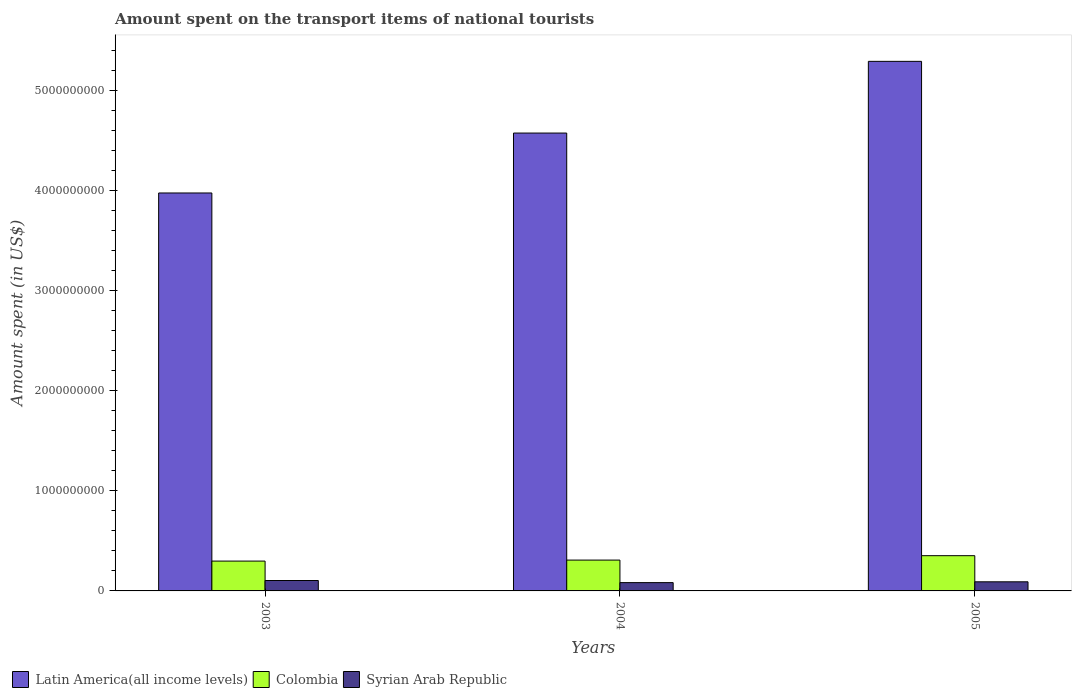Are the number of bars on each tick of the X-axis equal?
Your answer should be very brief. Yes. How many bars are there on the 1st tick from the right?
Your answer should be compact. 3. In how many cases, is the number of bars for a given year not equal to the number of legend labels?
Your answer should be compact. 0. What is the amount spent on the transport items of national tourists in Colombia in 2005?
Keep it short and to the point. 3.52e+08. Across all years, what is the maximum amount spent on the transport items of national tourists in Colombia?
Give a very brief answer. 3.52e+08. Across all years, what is the minimum amount spent on the transport items of national tourists in Colombia?
Your answer should be compact. 2.98e+08. In which year was the amount spent on the transport items of national tourists in Latin America(all income levels) maximum?
Your answer should be very brief. 2005. What is the total amount spent on the transport items of national tourists in Syrian Arab Republic in the graph?
Offer a terse response. 2.78e+08. What is the difference between the amount spent on the transport items of national tourists in Syrian Arab Republic in 2004 and that in 2005?
Make the answer very short. -8.00e+06. What is the difference between the amount spent on the transport items of national tourists in Colombia in 2005 and the amount spent on the transport items of national tourists in Latin America(all income levels) in 2004?
Offer a terse response. -4.22e+09. What is the average amount spent on the transport items of national tourists in Colombia per year?
Your answer should be compact. 3.19e+08. In the year 2004, what is the difference between the amount spent on the transport items of national tourists in Syrian Arab Republic and amount spent on the transport items of national tourists in Latin America(all income levels)?
Provide a succinct answer. -4.49e+09. In how many years, is the amount spent on the transport items of national tourists in Syrian Arab Republic greater than 3000000000 US$?
Offer a terse response. 0. What is the ratio of the amount spent on the transport items of national tourists in Colombia in 2003 to that in 2005?
Your answer should be compact. 0.85. Is the amount spent on the transport items of national tourists in Colombia in 2003 less than that in 2004?
Keep it short and to the point. Yes. Is the difference between the amount spent on the transport items of national tourists in Syrian Arab Republic in 2004 and 2005 greater than the difference between the amount spent on the transport items of national tourists in Latin America(all income levels) in 2004 and 2005?
Provide a succinct answer. Yes. What is the difference between the highest and the second highest amount spent on the transport items of national tourists in Syrian Arab Republic?
Provide a short and direct response. 1.30e+07. What is the difference between the highest and the lowest amount spent on the transport items of national tourists in Colombia?
Offer a terse response. 5.40e+07. In how many years, is the amount spent on the transport items of national tourists in Latin America(all income levels) greater than the average amount spent on the transport items of national tourists in Latin America(all income levels) taken over all years?
Your answer should be compact. 1. What does the 3rd bar from the left in 2003 represents?
Your answer should be very brief. Syrian Arab Republic. What does the 1st bar from the right in 2004 represents?
Keep it short and to the point. Syrian Arab Republic. How many bars are there?
Keep it short and to the point. 9. Are all the bars in the graph horizontal?
Provide a short and direct response. No. How many years are there in the graph?
Make the answer very short. 3. What is the difference between two consecutive major ticks on the Y-axis?
Your answer should be compact. 1.00e+09. Does the graph contain grids?
Offer a terse response. No. How many legend labels are there?
Offer a very short reply. 3. What is the title of the graph?
Offer a very short reply. Amount spent on the transport items of national tourists. Does "Spain" appear as one of the legend labels in the graph?
Your answer should be compact. No. What is the label or title of the Y-axis?
Give a very brief answer. Amount spent (in US$). What is the Amount spent (in US$) of Latin America(all income levels) in 2003?
Give a very brief answer. 3.98e+09. What is the Amount spent (in US$) in Colombia in 2003?
Keep it short and to the point. 2.98e+08. What is the Amount spent (in US$) of Syrian Arab Republic in 2003?
Provide a succinct answer. 1.04e+08. What is the Amount spent (in US$) of Latin America(all income levels) in 2004?
Ensure brevity in your answer.  4.57e+09. What is the Amount spent (in US$) in Colombia in 2004?
Provide a succinct answer. 3.08e+08. What is the Amount spent (in US$) of Syrian Arab Republic in 2004?
Give a very brief answer. 8.30e+07. What is the Amount spent (in US$) of Latin America(all income levels) in 2005?
Offer a very short reply. 5.29e+09. What is the Amount spent (in US$) of Colombia in 2005?
Give a very brief answer. 3.52e+08. What is the Amount spent (in US$) in Syrian Arab Republic in 2005?
Keep it short and to the point. 9.10e+07. Across all years, what is the maximum Amount spent (in US$) of Latin America(all income levels)?
Your response must be concise. 5.29e+09. Across all years, what is the maximum Amount spent (in US$) in Colombia?
Give a very brief answer. 3.52e+08. Across all years, what is the maximum Amount spent (in US$) of Syrian Arab Republic?
Offer a very short reply. 1.04e+08. Across all years, what is the minimum Amount spent (in US$) in Latin America(all income levels)?
Your response must be concise. 3.98e+09. Across all years, what is the minimum Amount spent (in US$) in Colombia?
Make the answer very short. 2.98e+08. Across all years, what is the minimum Amount spent (in US$) in Syrian Arab Republic?
Your answer should be compact. 8.30e+07. What is the total Amount spent (in US$) of Latin America(all income levels) in the graph?
Provide a short and direct response. 1.38e+1. What is the total Amount spent (in US$) in Colombia in the graph?
Provide a succinct answer. 9.58e+08. What is the total Amount spent (in US$) in Syrian Arab Republic in the graph?
Your answer should be compact. 2.78e+08. What is the difference between the Amount spent (in US$) in Latin America(all income levels) in 2003 and that in 2004?
Ensure brevity in your answer.  -5.99e+08. What is the difference between the Amount spent (in US$) of Colombia in 2003 and that in 2004?
Offer a terse response. -1.00e+07. What is the difference between the Amount spent (in US$) in Syrian Arab Republic in 2003 and that in 2004?
Your answer should be compact. 2.10e+07. What is the difference between the Amount spent (in US$) of Latin America(all income levels) in 2003 and that in 2005?
Your answer should be compact. -1.31e+09. What is the difference between the Amount spent (in US$) in Colombia in 2003 and that in 2005?
Ensure brevity in your answer.  -5.40e+07. What is the difference between the Amount spent (in US$) of Syrian Arab Republic in 2003 and that in 2005?
Provide a short and direct response. 1.30e+07. What is the difference between the Amount spent (in US$) of Latin America(all income levels) in 2004 and that in 2005?
Make the answer very short. -7.16e+08. What is the difference between the Amount spent (in US$) in Colombia in 2004 and that in 2005?
Your answer should be very brief. -4.40e+07. What is the difference between the Amount spent (in US$) of Syrian Arab Republic in 2004 and that in 2005?
Offer a terse response. -8.00e+06. What is the difference between the Amount spent (in US$) in Latin America(all income levels) in 2003 and the Amount spent (in US$) in Colombia in 2004?
Give a very brief answer. 3.67e+09. What is the difference between the Amount spent (in US$) in Latin America(all income levels) in 2003 and the Amount spent (in US$) in Syrian Arab Republic in 2004?
Your answer should be compact. 3.89e+09. What is the difference between the Amount spent (in US$) of Colombia in 2003 and the Amount spent (in US$) of Syrian Arab Republic in 2004?
Your response must be concise. 2.15e+08. What is the difference between the Amount spent (in US$) in Latin America(all income levels) in 2003 and the Amount spent (in US$) in Colombia in 2005?
Your response must be concise. 3.62e+09. What is the difference between the Amount spent (in US$) of Latin America(all income levels) in 2003 and the Amount spent (in US$) of Syrian Arab Republic in 2005?
Offer a terse response. 3.88e+09. What is the difference between the Amount spent (in US$) of Colombia in 2003 and the Amount spent (in US$) of Syrian Arab Republic in 2005?
Offer a terse response. 2.07e+08. What is the difference between the Amount spent (in US$) in Latin America(all income levels) in 2004 and the Amount spent (in US$) in Colombia in 2005?
Provide a succinct answer. 4.22e+09. What is the difference between the Amount spent (in US$) of Latin America(all income levels) in 2004 and the Amount spent (in US$) of Syrian Arab Republic in 2005?
Keep it short and to the point. 4.48e+09. What is the difference between the Amount spent (in US$) of Colombia in 2004 and the Amount spent (in US$) of Syrian Arab Republic in 2005?
Keep it short and to the point. 2.17e+08. What is the average Amount spent (in US$) in Latin America(all income levels) per year?
Offer a terse response. 4.61e+09. What is the average Amount spent (in US$) of Colombia per year?
Provide a succinct answer. 3.19e+08. What is the average Amount spent (in US$) of Syrian Arab Republic per year?
Give a very brief answer. 9.27e+07. In the year 2003, what is the difference between the Amount spent (in US$) of Latin America(all income levels) and Amount spent (in US$) of Colombia?
Provide a succinct answer. 3.68e+09. In the year 2003, what is the difference between the Amount spent (in US$) in Latin America(all income levels) and Amount spent (in US$) in Syrian Arab Republic?
Make the answer very short. 3.87e+09. In the year 2003, what is the difference between the Amount spent (in US$) of Colombia and Amount spent (in US$) of Syrian Arab Republic?
Provide a short and direct response. 1.94e+08. In the year 2004, what is the difference between the Amount spent (in US$) of Latin America(all income levels) and Amount spent (in US$) of Colombia?
Offer a very short reply. 4.27e+09. In the year 2004, what is the difference between the Amount spent (in US$) in Latin America(all income levels) and Amount spent (in US$) in Syrian Arab Republic?
Offer a terse response. 4.49e+09. In the year 2004, what is the difference between the Amount spent (in US$) in Colombia and Amount spent (in US$) in Syrian Arab Republic?
Your answer should be very brief. 2.25e+08. In the year 2005, what is the difference between the Amount spent (in US$) in Latin America(all income levels) and Amount spent (in US$) in Colombia?
Provide a succinct answer. 4.94e+09. In the year 2005, what is the difference between the Amount spent (in US$) of Latin America(all income levels) and Amount spent (in US$) of Syrian Arab Republic?
Offer a very short reply. 5.20e+09. In the year 2005, what is the difference between the Amount spent (in US$) in Colombia and Amount spent (in US$) in Syrian Arab Republic?
Your answer should be very brief. 2.61e+08. What is the ratio of the Amount spent (in US$) of Latin America(all income levels) in 2003 to that in 2004?
Ensure brevity in your answer.  0.87. What is the ratio of the Amount spent (in US$) in Colombia in 2003 to that in 2004?
Provide a succinct answer. 0.97. What is the ratio of the Amount spent (in US$) in Syrian Arab Republic in 2003 to that in 2004?
Provide a succinct answer. 1.25. What is the ratio of the Amount spent (in US$) of Latin America(all income levels) in 2003 to that in 2005?
Give a very brief answer. 0.75. What is the ratio of the Amount spent (in US$) of Colombia in 2003 to that in 2005?
Offer a terse response. 0.85. What is the ratio of the Amount spent (in US$) in Syrian Arab Republic in 2003 to that in 2005?
Provide a succinct answer. 1.14. What is the ratio of the Amount spent (in US$) of Latin America(all income levels) in 2004 to that in 2005?
Your answer should be very brief. 0.86. What is the ratio of the Amount spent (in US$) of Syrian Arab Republic in 2004 to that in 2005?
Give a very brief answer. 0.91. What is the difference between the highest and the second highest Amount spent (in US$) in Latin America(all income levels)?
Your answer should be compact. 7.16e+08. What is the difference between the highest and the second highest Amount spent (in US$) of Colombia?
Keep it short and to the point. 4.40e+07. What is the difference between the highest and the second highest Amount spent (in US$) in Syrian Arab Republic?
Keep it short and to the point. 1.30e+07. What is the difference between the highest and the lowest Amount spent (in US$) of Latin America(all income levels)?
Give a very brief answer. 1.31e+09. What is the difference between the highest and the lowest Amount spent (in US$) in Colombia?
Your answer should be very brief. 5.40e+07. What is the difference between the highest and the lowest Amount spent (in US$) in Syrian Arab Republic?
Your answer should be compact. 2.10e+07. 